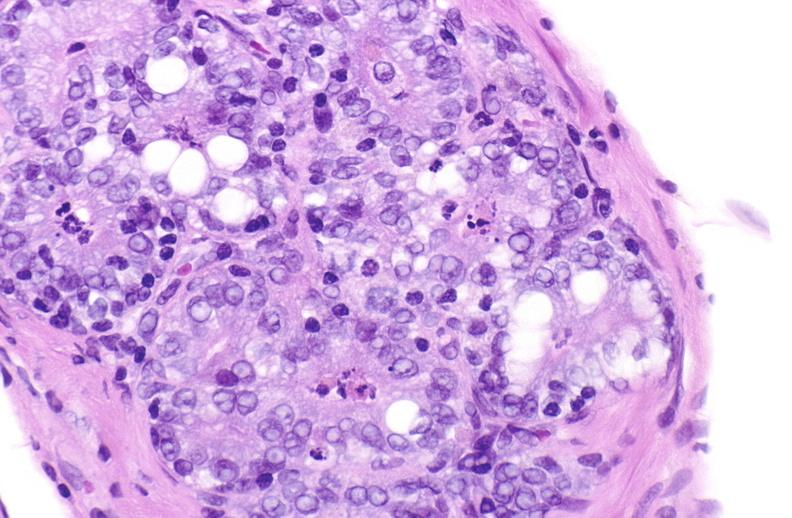does this image show apoptosis in prostate after orchiectomy?
Answer the question using a single word or phrase. Yes 